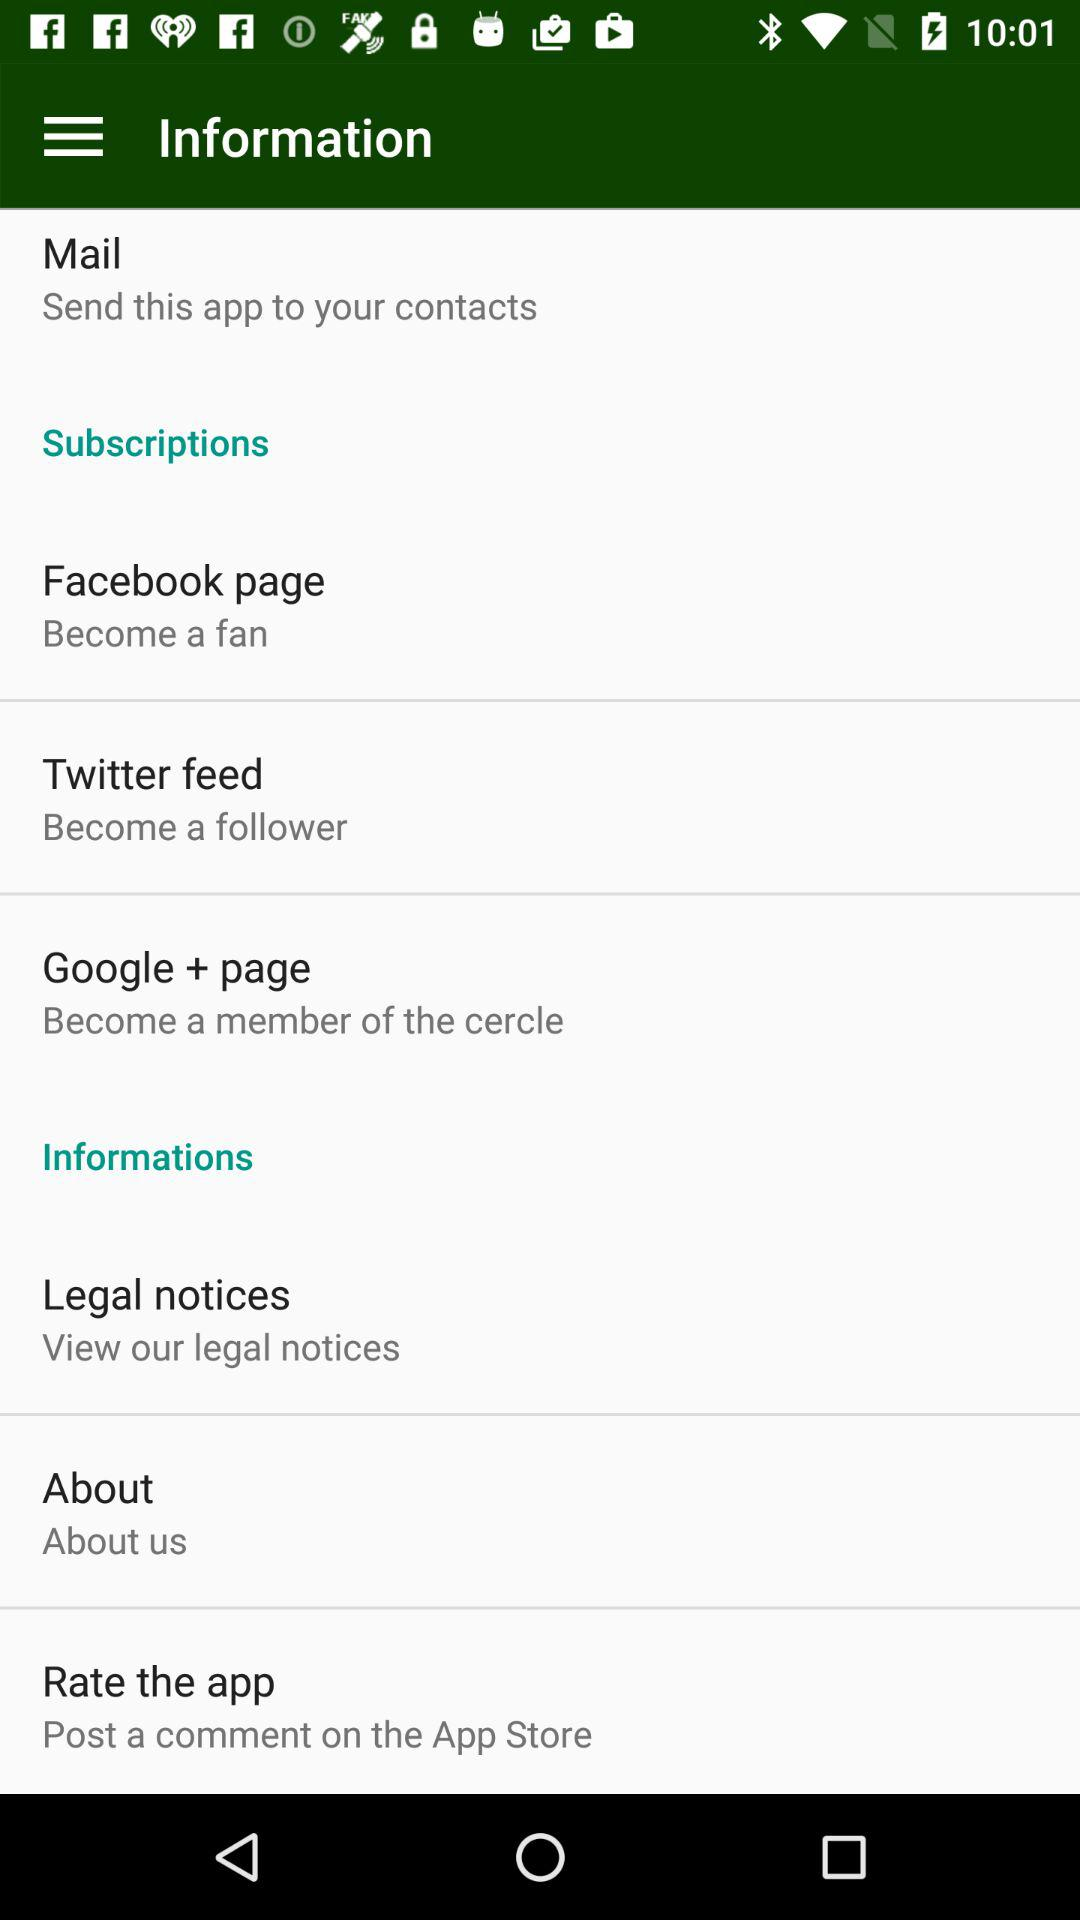What is the description of Twitter feed? The description of Twitter feed is "Become a follower". 